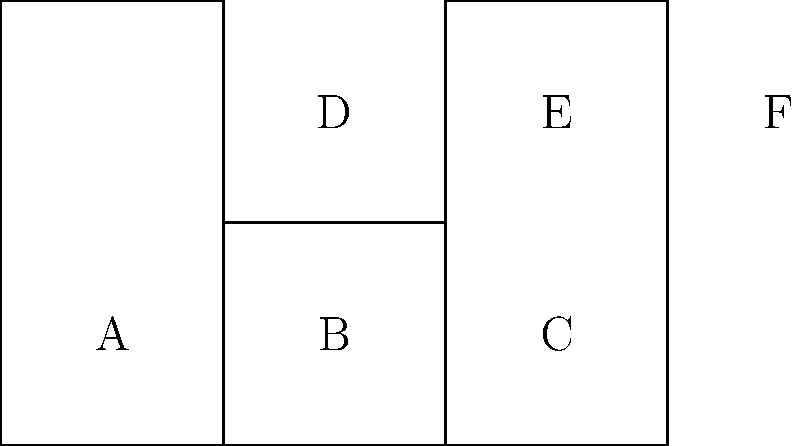As a software developer working on a betting platform, you need to implement a 3D dice rolling animation. Given the 2D net of a cube shown above, which face will be opposite to face F when the net is folded into a cube? To solve this problem, we need to mentally fold the 2D net into a 3D cube. Let's follow these steps:

1. Identify the base face: Let's choose face C as the base of the cube.

2. Fold the adjacent faces:
   - Face B folds up to form the front face
   - Face D folds up to form the top face
   - Face E remains flat and becomes the back face
   - Face F folds down to form the right face

3. Determine the position of face A:
   - Face A is connected to face B
   - When B folds up, A will fold to the left, forming the left face of the cube

4. Identify the opposite faces:
   - A is opposite to F
   - B is opposite to E
   - C is opposite to D

Therefore, when the net is folded into a cube, face A will be opposite to face F.

This spatial reasoning is crucial in developing accurate 3D animations for dice rolling in a betting platform, ensuring that the dice behave realistically and maintain the correct opposite face relationships.
Answer: A 